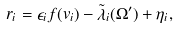Convert formula to latex. <formula><loc_0><loc_0><loc_500><loc_500>r _ { i } = \epsilon _ { i } f ( v _ { i } ) - \tilde { \lambda } _ { i } ( \Omega ^ { \prime } ) + \eta _ { i } ,</formula> 